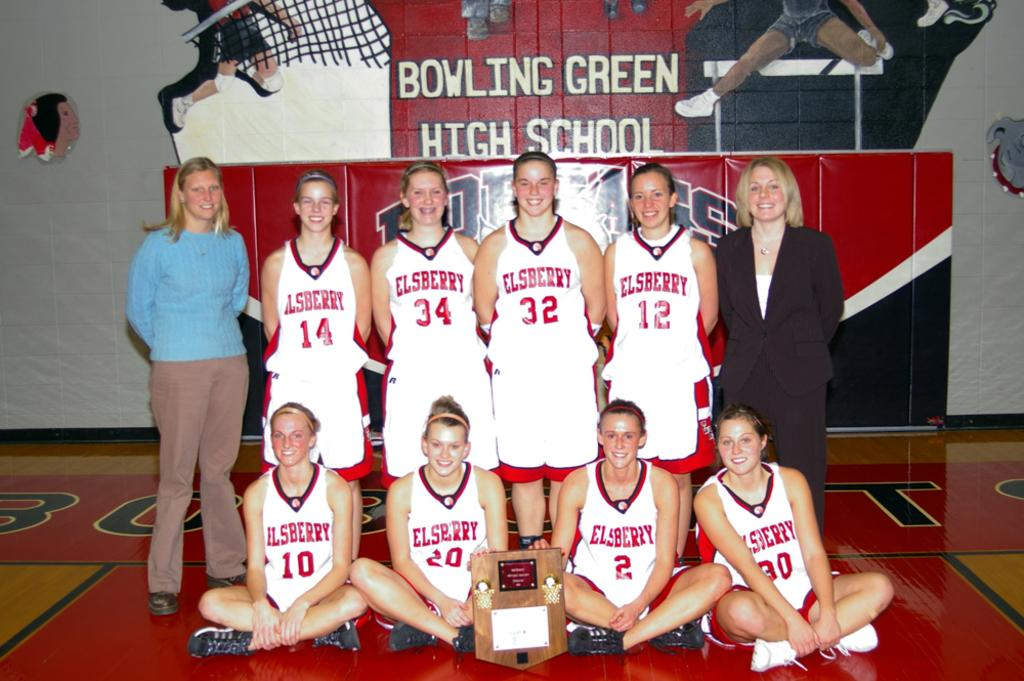Provide a one-sentence caption for the provided image. A team is taking a picture in a gym at Bowling Green High School. 